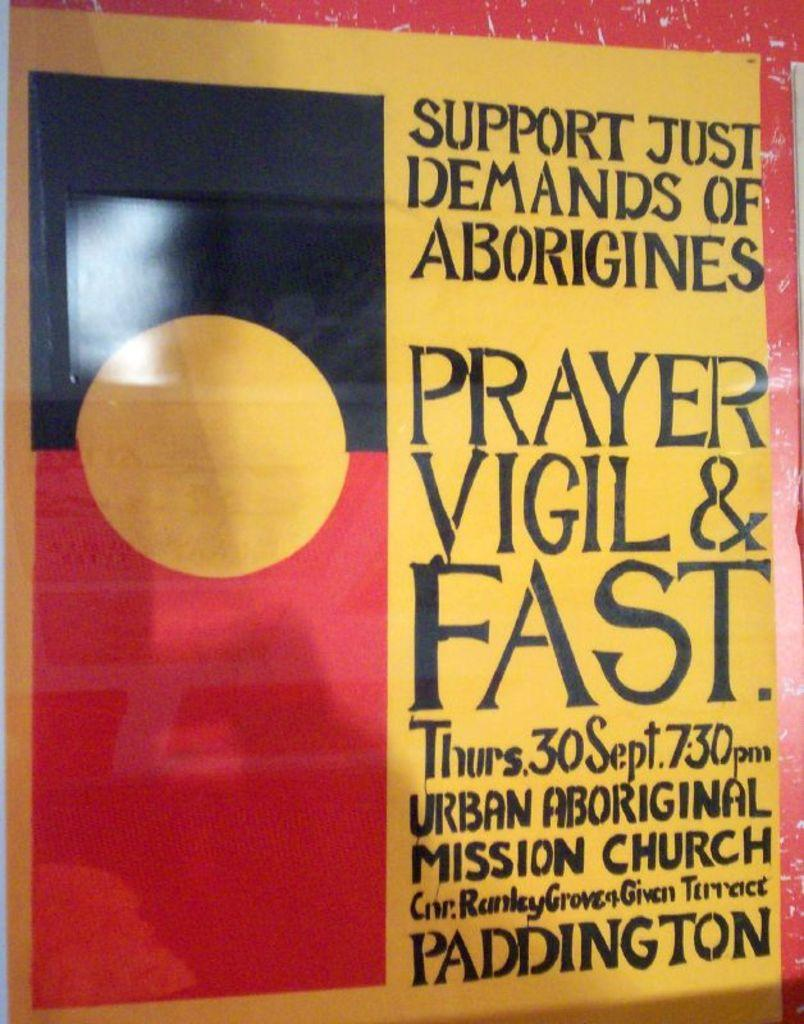Provide a one-sentence caption for the provided image. "Supporting Aborigines through prayer" is written on this poster. 